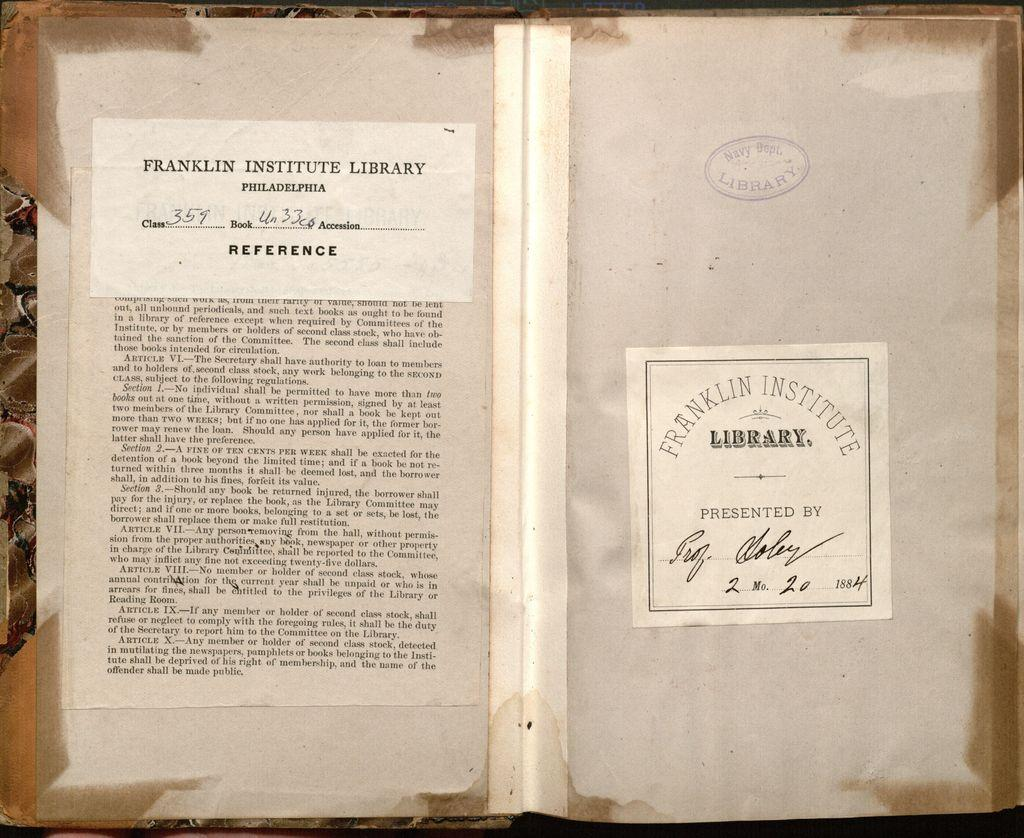<image>
Present a compact description of the photo's key features. A tag on the book states it belongs to Franklin Institute Library. 